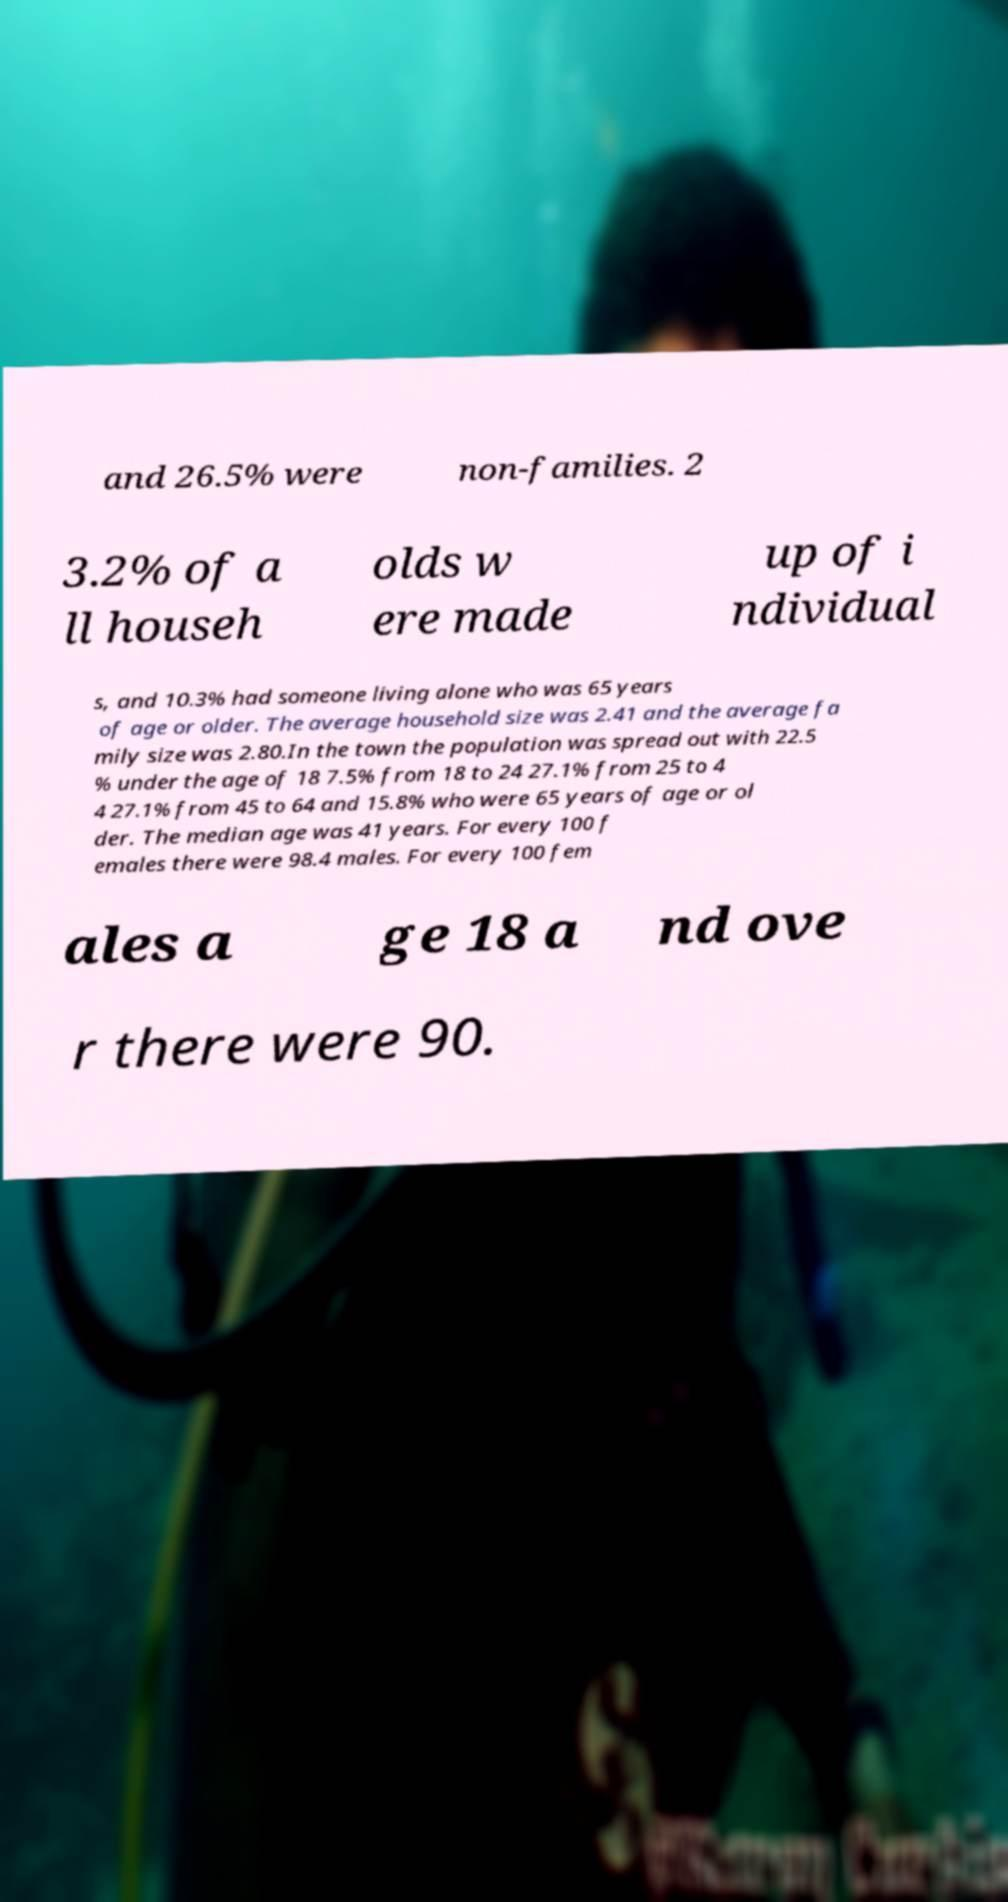Could you assist in decoding the text presented in this image and type it out clearly? and 26.5% were non-families. 2 3.2% of a ll househ olds w ere made up of i ndividual s, and 10.3% had someone living alone who was 65 years of age or older. The average household size was 2.41 and the average fa mily size was 2.80.In the town the population was spread out with 22.5 % under the age of 18 7.5% from 18 to 24 27.1% from 25 to 4 4 27.1% from 45 to 64 and 15.8% who were 65 years of age or ol der. The median age was 41 years. For every 100 f emales there were 98.4 males. For every 100 fem ales a ge 18 a nd ove r there were 90. 